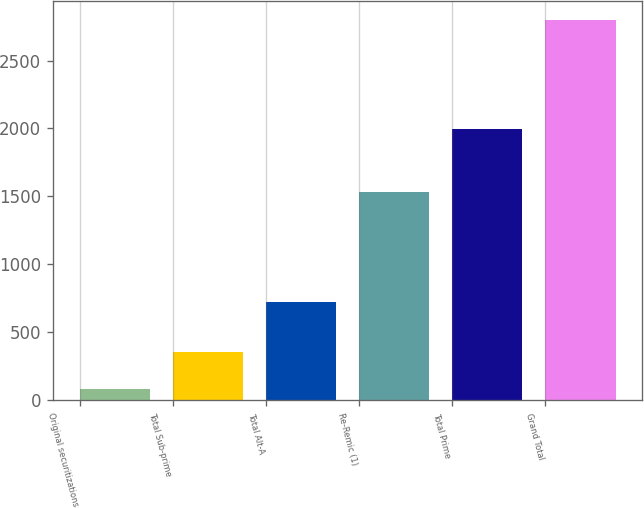<chart> <loc_0><loc_0><loc_500><loc_500><bar_chart><fcel>Original securitizations<fcel>Total Sub-prime<fcel>Total Alt-A<fcel>Re-Remic (1)<fcel>Total Prime<fcel>Grand Total<nl><fcel>80<fcel>351.5<fcel>720<fcel>1534<fcel>1993<fcel>2795<nl></chart> 